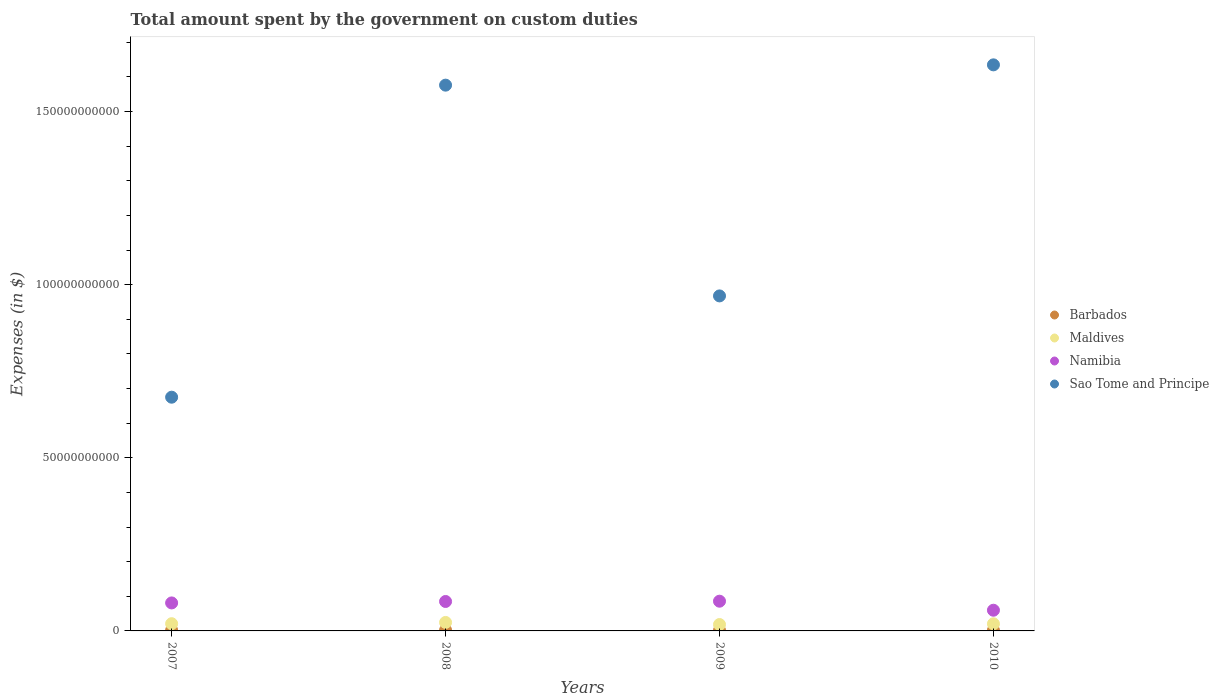How many different coloured dotlines are there?
Make the answer very short. 4. Is the number of dotlines equal to the number of legend labels?
Ensure brevity in your answer.  Yes. What is the amount spent on custom duties by the government in Namibia in 2009?
Your response must be concise. 8.59e+09. Across all years, what is the maximum amount spent on custom duties by the government in Sao Tome and Principe?
Provide a succinct answer. 1.63e+11. Across all years, what is the minimum amount spent on custom duties by the government in Namibia?
Your answer should be compact. 5.98e+09. In which year was the amount spent on custom duties by the government in Sao Tome and Principe minimum?
Your answer should be compact. 2007. What is the total amount spent on custom duties by the government in Barbados in the graph?
Your answer should be very brief. 8.05e+08. What is the difference between the amount spent on custom duties by the government in Namibia in 2008 and that in 2009?
Offer a very short reply. -8.30e+07. What is the difference between the amount spent on custom duties by the government in Barbados in 2010 and the amount spent on custom duties by the government in Maldives in 2008?
Give a very brief answer. -2.26e+09. What is the average amount spent on custom duties by the government in Barbados per year?
Provide a succinct answer. 2.01e+08. In the year 2008, what is the difference between the amount spent on custom duties by the government in Barbados and amount spent on custom duties by the government in Sao Tome and Principe?
Make the answer very short. -1.57e+11. What is the ratio of the amount spent on custom duties by the government in Sao Tome and Principe in 2007 to that in 2009?
Your response must be concise. 0.7. What is the difference between the highest and the second highest amount spent on custom duties by the government in Sao Tome and Principe?
Ensure brevity in your answer.  5.86e+09. What is the difference between the highest and the lowest amount spent on custom duties by the government in Maldives?
Provide a short and direct response. 6.00e+08. Is it the case that in every year, the sum of the amount spent on custom duties by the government in Sao Tome and Principe and amount spent on custom duties by the government in Maldives  is greater than the sum of amount spent on custom duties by the government in Namibia and amount spent on custom duties by the government in Barbados?
Your answer should be very brief. No. Does the amount spent on custom duties by the government in Barbados monotonically increase over the years?
Keep it short and to the point. No. How many years are there in the graph?
Your answer should be very brief. 4. Are the values on the major ticks of Y-axis written in scientific E-notation?
Make the answer very short. No. Does the graph contain any zero values?
Offer a very short reply. No. Does the graph contain grids?
Offer a very short reply. No. What is the title of the graph?
Offer a terse response. Total amount spent by the government on custom duties. What is the label or title of the X-axis?
Keep it short and to the point. Years. What is the label or title of the Y-axis?
Provide a short and direct response. Expenses (in $). What is the Expenses (in $) of Barbados in 2007?
Make the answer very short. 2.17e+08. What is the Expenses (in $) in Maldives in 2007?
Offer a terse response. 2.09e+09. What is the Expenses (in $) of Namibia in 2007?
Your answer should be very brief. 8.09e+09. What is the Expenses (in $) of Sao Tome and Principe in 2007?
Your answer should be very brief. 6.75e+1. What is the Expenses (in $) of Barbados in 2008?
Your response must be concise. 2.19e+08. What is the Expenses (in $) in Maldives in 2008?
Offer a terse response. 2.45e+09. What is the Expenses (in $) in Namibia in 2008?
Ensure brevity in your answer.  8.50e+09. What is the Expenses (in $) of Sao Tome and Principe in 2008?
Offer a very short reply. 1.58e+11. What is the Expenses (in $) of Barbados in 2009?
Ensure brevity in your answer.  1.78e+08. What is the Expenses (in $) in Maldives in 2009?
Your answer should be compact. 1.85e+09. What is the Expenses (in $) of Namibia in 2009?
Give a very brief answer. 8.59e+09. What is the Expenses (in $) in Sao Tome and Principe in 2009?
Make the answer very short. 9.67e+1. What is the Expenses (in $) of Barbados in 2010?
Your answer should be very brief. 1.91e+08. What is the Expenses (in $) of Maldives in 2010?
Make the answer very short. 2.06e+09. What is the Expenses (in $) in Namibia in 2010?
Your answer should be compact. 5.98e+09. What is the Expenses (in $) in Sao Tome and Principe in 2010?
Keep it short and to the point. 1.63e+11. Across all years, what is the maximum Expenses (in $) of Barbados?
Ensure brevity in your answer.  2.19e+08. Across all years, what is the maximum Expenses (in $) of Maldives?
Ensure brevity in your answer.  2.45e+09. Across all years, what is the maximum Expenses (in $) in Namibia?
Offer a terse response. 8.59e+09. Across all years, what is the maximum Expenses (in $) in Sao Tome and Principe?
Provide a succinct answer. 1.63e+11. Across all years, what is the minimum Expenses (in $) of Barbados?
Provide a succinct answer. 1.78e+08. Across all years, what is the minimum Expenses (in $) of Maldives?
Keep it short and to the point. 1.85e+09. Across all years, what is the minimum Expenses (in $) of Namibia?
Provide a succinct answer. 5.98e+09. Across all years, what is the minimum Expenses (in $) in Sao Tome and Principe?
Make the answer very short. 6.75e+1. What is the total Expenses (in $) of Barbados in the graph?
Offer a terse response. 8.05e+08. What is the total Expenses (in $) in Maldives in the graph?
Keep it short and to the point. 8.44e+09. What is the total Expenses (in $) in Namibia in the graph?
Give a very brief answer. 3.11e+1. What is the total Expenses (in $) in Sao Tome and Principe in the graph?
Your response must be concise. 4.85e+11. What is the difference between the Expenses (in $) of Barbados in 2007 and that in 2008?
Provide a short and direct response. -2.52e+06. What is the difference between the Expenses (in $) in Maldives in 2007 and that in 2008?
Your answer should be very brief. -3.62e+08. What is the difference between the Expenses (in $) of Namibia in 2007 and that in 2008?
Keep it short and to the point. -4.17e+08. What is the difference between the Expenses (in $) in Sao Tome and Principe in 2007 and that in 2008?
Make the answer very short. -9.01e+1. What is the difference between the Expenses (in $) in Barbados in 2007 and that in 2009?
Keep it short and to the point. 3.90e+07. What is the difference between the Expenses (in $) of Maldives in 2007 and that in 2009?
Keep it short and to the point. 2.38e+08. What is the difference between the Expenses (in $) in Namibia in 2007 and that in 2009?
Offer a very short reply. -5.00e+08. What is the difference between the Expenses (in $) in Sao Tome and Principe in 2007 and that in 2009?
Keep it short and to the point. -2.93e+1. What is the difference between the Expenses (in $) of Barbados in 2007 and that in 2010?
Ensure brevity in your answer.  2.61e+07. What is the difference between the Expenses (in $) in Maldives in 2007 and that in 2010?
Make the answer very short. 3.07e+07. What is the difference between the Expenses (in $) in Namibia in 2007 and that in 2010?
Offer a very short reply. 2.11e+09. What is the difference between the Expenses (in $) in Sao Tome and Principe in 2007 and that in 2010?
Keep it short and to the point. -9.60e+1. What is the difference between the Expenses (in $) of Barbados in 2008 and that in 2009?
Provide a short and direct response. 4.15e+07. What is the difference between the Expenses (in $) in Maldives in 2008 and that in 2009?
Your answer should be very brief. 6.00e+08. What is the difference between the Expenses (in $) in Namibia in 2008 and that in 2009?
Make the answer very short. -8.30e+07. What is the difference between the Expenses (in $) of Sao Tome and Principe in 2008 and that in 2009?
Provide a succinct answer. 6.09e+1. What is the difference between the Expenses (in $) of Barbados in 2008 and that in 2010?
Make the answer very short. 2.87e+07. What is the difference between the Expenses (in $) of Maldives in 2008 and that in 2010?
Your answer should be very brief. 3.93e+08. What is the difference between the Expenses (in $) in Namibia in 2008 and that in 2010?
Make the answer very short. 2.53e+09. What is the difference between the Expenses (in $) in Sao Tome and Principe in 2008 and that in 2010?
Ensure brevity in your answer.  -5.86e+09. What is the difference between the Expenses (in $) in Barbados in 2009 and that in 2010?
Make the answer very short. -1.28e+07. What is the difference between the Expenses (in $) in Maldives in 2009 and that in 2010?
Offer a very short reply. -2.07e+08. What is the difference between the Expenses (in $) of Namibia in 2009 and that in 2010?
Provide a succinct answer. 2.61e+09. What is the difference between the Expenses (in $) of Sao Tome and Principe in 2009 and that in 2010?
Make the answer very short. -6.67e+1. What is the difference between the Expenses (in $) of Barbados in 2007 and the Expenses (in $) of Maldives in 2008?
Your answer should be compact. -2.23e+09. What is the difference between the Expenses (in $) of Barbados in 2007 and the Expenses (in $) of Namibia in 2008?
Your answer should be compact. -8.29e+09. What is the difference between the Expenses (in $) in Barbados in 2007 and the Expenses (in $) in Sao Tome and Principe in 2008?
Give a very brief answer. -1.57e+11. What is the difference between the Expenses (in $) in Maldives in 2007 and the Expenses (in $) in Namibia in 2008?
Keep it short and to the point. -6.42e+09. What is the difference between the Expenses (in $) in Maldives in 2007 and the Expenses (in $) in Sao Tome and Principe in 2008?
Keep it short and to the point. -1.56e+11. What is the difference between the Expenses (in $) in Namibia in 2007 and the Expenses (in $) in Sao Tome and Principe in 2008?
Your response must be concise. -1.50e+11. What is the difference between the Expenses (in $) of Barbados in 2007 and the Expenses (in $) of Maldives in 2009?
Provide a short and direct response. -1.63e+09. What is the difference between the Expenses (in $) in Barbados in 2007 and the Expenses (in $) in Namibia in 2009?
Ensure brevity in your answer.  -8.37e+09. What is the difference between the Expenses (in $) of Barbados in 2007 and the Expenses (in $) of Sao Tome and Principe in 2009?
Provide a succinct answer. -9.65e+1. What is the difference between the Expenses (in $) in Maldives in 2007 and the Expenses (in $) in Namibia in 2009?
Offer a terse response. -6.50e+09. What is the difference between the Expenses (in $) of Maldives in 2007 and the Expenses (in $) of Sao Tome and Principe in 2009?
Ensure brevity in your answer.  -9.47e+1. What is the difference between the Expenses (in $) in Namibia in 2007 and the Expenses (in $) in Sao Tome and Principe in 2009?
Ensure brevity in your answer.  -8.87e+1. What is the difference between the Expenses (in $) in Barbados in 2007 and the Expenses (in $) in Maldives in 2010?
Your answer should be compact. -1.84e+09. What is the difference between the Expenses (in $) of Barbados in 2007 and the Expenses (in $) of Namibia in 2010?
Provide a succinct answer. -5.76e+09. What is the difference between the Expenses (in $) of Barbados in 2007 and the Expenses (in $) of Sao Tome and Principe in 2010?
Make the answer very short. -1.63e+11. What is the difference between the Expenses (in $) in Maldives in 2007 and the Expenses (in $) in Namibia in 2010?
Provide a short and direct response. -3.89e+09. What is the difference between the Expenses (in $) in Maldives in 2007 and the Expenses (in $) in Sao Tome and Principe in 2010?
Give a very brief answer. -1.61e+11. What is the difference between the Expenses (in $) in Namibia in 2007 and the Expenses (in $) in Sao Tome and Principe in 2010?
Your response must be concise. -1.55e+11. What is the difference between the Expenses (in $) of Barbados in 2008 and the Expenses (in $) of Maldives in 2009?
Ensure brevity in your answer.  -1.63e+09. What is the difference between the Expenses (in $) in Barbados in 2008 and the Expenses (in $) in Namibia in 2009?
Ensure brevity in your answer.  -8.37e+09. What is the difference between the Expenses (in $) of Barbados in 2008 and the Expenses (in $) of Sao Tome and Principe in 2009?
Offer a terse response. -9.65e+1. What is the difference between the Expenses (in $) in Maldives in 2008 and the Expenses (in $) in Namibia in 2009?
Keep it short and to the point. -6.14e+09. What is the difference between the Expenses (in $) of Maldives in 2008 and the Expenses (in $) of Sao Tome and Principe in 2009?
Your answer should be compact. -9.43e+1. What is the difference between the Expenses (in $) in Namibia in 2008 and the Expenses (in $) in Sao Tome and Principe in 2009?
Your answer should be compact. -8.82e+1. What is the difference between the Expenses (in $) of Barbados in 2008 and the Expenses (in $) of Maldives in 2010?
Your response must be concise. -1.84e+09. What is the difference between the Expenses (in $) in Barbados in 2008 and the Expenses (in $) in Namibia in 2010?
Provide a succinct answer. -5.76e+09. What is the difference between the Expenses (in $) of Barbados in 2008 and the Expenses (in $) of Sao Tome and Principe in 2010?
Keep it short and to the point. -1.63e+11. What is the difference between the Expenses (in $) of Maldives in 2008 and the Expenses (in $) of Namibia in 2010?
Your answer should be compact. -3.53e+09. What is the difference between the Expenses (in $) in Maldives in 2008 and the Expenses (in $) in Sao Tome and Principe in 2010?
Provide a succinct answer. -1.61e+11. What is the difference between the Expenses (in $) of Namibia in 2008 and the Expenses (in $) of Sao Tome and Principe in 2010?
Your answer should be very brief. -1.55e+11. What is the difference between the Expenses (in $) in Barbados in 2009 and the Expenses (in $) in Maldives in 2010?
Make the answer very short. -1.88e+09. What is the difference between the Expenses (in $) in Barbados in 2009 and the Expenses (in $) in Namibia in 2010?
Ensure brevity in your answer.  -5.80e+09. What is the difference between the Expenses (in $) in Barbados in 2009 and the Expenses (in $) in Sao Tome and Principe in 2010?
Make the answer very short. -1.63e+11. What is the difference between the Expenses (in $) of Maldives in 2009 and the Expenses (in $) of Namibia in 2010?
Provide a short and direct response. -4.13e+09. What is the difference between the Expenses (in $) in Maldives in 2009 and the Expenses (in $) in Sao Tome and Principe in 2010?
Your response must be concise. -1.62e+11. What is the difference between the Expenses (in $) in Namibia in 2009 and the Expenses (in $) in Sao Tome and Principe in 2010?
Offer a terse response. -1.55e+11. What is the average Expenses (in $) in Barbados per year?
Ensure brevity in your answer.  2.01e+08. What is the average Expenses (in $) of Maldives per year?
Offer a very short reply. 2.11e+09. What is the average Expenses (in $) of Namibia per year?
Your response must be concise. 7.79e+09. What is the average Expenses (in $) in Sao Tome and Principe per year?
Offer a terse response. 1.21e+11. In the year 2007, what is the difference between the Expenses (in $) of Barbados and Expenses (in $) of Maldives?
Ensure brevity in your answer.  -1.87e+09. In the year 2007, what is the difference between the Expenses (in $) of Barbados and Expenses (in $) of Namibia?
Provide a succinct answer. -7.87e+09. In the year 2007, what is the difference between the Expenses (in $) of Barbados and Expenses (in $) of Sao Tome and Principe?
Provide a succinct answer. -6.73e+1. In the year 2007, what is the difference between the Expenses (in $) of Maldives and Expenses (in $) of Namibia?
Make the answer very short. -6.00e+09. In the year 2007, what is the difference between the Expenses (in $) of Maldives and Expenses (in $) of Sao Tome and Principe?
Make the answer very short. -6.54e+1. In the year 2007, what is the difference between the Expenses (in $) in Namibia and Expenses (in $) in Sao Tome and Principe?
Ensure brevity in your answer.  -5.94e+1. In the year 2008, what is the difference between the Expenses (in $) of Barbados and Expenses (in $) of Maldives?
Provide a short and direct response. -2.23e+09. In the year 2008, what is the difference between the Expenses (in $) of Barbados and Expenses (in $) of Namibia?
Provide a short and direct response. -8.28e+09. In the year 2008, what is the difference between the Expenses (in $) in Barbados and Expenses (in $) in Sao Tome and Principe?
Keep it short and to the point. -1.57e+11. In the year 2008, what is the difference between the Expenses (in $) in Maldives and Expenses (in $) in Namibia?
Provide a short and direct response. -6.05e+09. In the year 2008, what is the difference between the Expenses (in $) of Maldives and Expenses (in $) of Sao Tome and Principe?
Keep it short and to the point. -1.55e+11. In the year 2008, what is the difference between the Expenses (in $) in Namibia and Expenses (in $) in Sao Tome and Principe?
Ensure brevity in your answer.  -1.49e+11. In the year 2009, what is the difference between the Expenses (in $) in Barbados and Expenses (in $) in Maldives?
Provide a short and direct response. -1.67e+09. In the year 2009, what is the difference between the Expenses (in $) in Barbados and Expenses (in $) in Namibia?
Offer a very short reply. -8.41e+09. In the year 2009, what is the difference between the Expenses (in $) of Barbados and Expenses (in $) of Sao Tome and Principe?
Your answer should be very brief. -9.66e+1. In the year 2009, what is the difference between the Expenses (in $) in Maldives and Expenses (in $) in Namibia?
Give a very brief answer. -6.74e+09. In the year 2009, what is the difference between the Expenses (in $) in Maldives and Expenses (in $) in Sao Tome and Principe?
Provide a short and direct response. -9.49e+1. In the year 2009, what is the difference between the Expenses (in $) in Namibia and Expenses (in $) in Sao Tome and Principe?
Provide a succinct answer. -8.82e+1. In the year 2010, what is the difference between the Expenses (in $) in Barbados and Expenses (in $) in Maldives?
Make the answer very short. -1.87e+09. In the year 2010, what is the difference between the Expenses (in $) of Barbados and Expenses (in $) of Namibia?
Your response must be concise. -5.79e+09. In the year 2010, what is the difference between the Expenses (in $) in Barbados and Expenses (in $) in Sao Tome and Principe?
Provide a succinct answer. -1.63e+11. In the year 2010, what is the difference between the Expenses (in $) in Maldives and Expenses (in $) in Namibia?
Offer a terse response. -3.92e+09. In the year 2010, what is the difference between the Expenses (in $) in Maldives and Expenses (in $) in Sao Tome and Principe?
Offer a terse response. -1.61e+11. In the year 2010, what is the difference between the Expenses (in $) in Namibia and Expenses (in $) in Sao Tome and Principe?
Offer a terse response. -1.58e+11. What is the ratio of the Expenses (in $) of Barbados in 2007 to that in 2008?
Make the answer very short. 0.99. What is the ratio of the Expenses (in $) in Maldives in 2007 to that in 2008?
Keep it short and to the point. 0.85. What is the ratio of the Expenses (in $) in Namibia in 2007 to that in 2008?
Provide a short and direct response. 0.95. What is the ratio of the Expenses (in $) of Sao Tome and Principe in 2007 to that in 2008?
Offer a very short reply. 0.43. What is the ratio of the Expenses (in $) of Barbados in 2007 to that in 2009?
Make the answer very short. 1.22. What is the ratio of the Expenses (in $) of Maldives in 2007 to that in 2009?
Your answer should be very brief. 1.13. What is the ratio of the Expenses (in $) in Namibia in 2007 to that in 2009?
Offer a very short reply. 0.94. What is the ratio of the Expenses (in $) of Sao Tome and Principe in 2007 to that in 2009?
Your response must be concise. 0.7. What is the ratio of the Expenses (in $) in Barbados in 2007 to that in 2010?
Offer a very short reply. 1.14. What is the ratio of the Expenses (in $) in Maldives in 2007 to that in 2010?
Your answer should be compact. 1.01. What is the ratio of the Expenses (in $) of Namibia in 2007 to that in 2010?
Your answer should be very brief. 1.35. What is the ratio of the Expenses (in $) in Sao Tome and Principe in 2007 to that in 2010?
Your answer should be very brief. 0.41. What is the ratio of the Expenses (in $) in Barbados in 2008 to that in 2009?
Your answer should be very brief. 1.23. What is the ratio of the Expenses (in $) of Maldives in 2008 to that in 2009?
Give a very brief answer. 1.32. What is the ratio of the Expenses (in $) of Namibia in 2008 to that in 2009?
Provide a succinct answer. 0.99. What is the ratio of the Expenses (in $) of Sao Tome and Principe in 2008 to that in 2009?
Provide a short and direct response. 1.63. What is the ratio of the Expenses (in $) in Barbados in 2008 to that in 2010?
Provide a succinct answer. 1.15. What is the ratio of the Expenses (in $) in Maldives in 2008 to that in 2010?
Provide a short and direct response. 1.19. What is the ratio of the Expenses (in $) in Namibia in 2008 to that in 2010?
Offer a very short reply. 1.42. What is the ratio of the Expenses (in $) in Sao Tome and Principe in 2008 to that in 2010?
Offer a terse response. 0.96. What is the ratio of the Expenses (in $) in Barbados in 2009 to that in 2010?
Provide a short and direct response. 0.93. What is the ratio of the Expenses (in $) in Maldives in 2009 to that in 2010?
Your answer should be compact. 0.9. What is the ratio of the Expenses (in $) in Namibia in 2009 to that in 2010?
Your answer should be very brief. 1.44. What is the ratio of the Expenses (in $) in Sao Tome and Principe in 2009 to that in 2010?
Make the answer very short. 0.59. What is the difference between the highest and the second highest Expenses (in $) in Barbados?
Keep it short and to the point. 2.52e+06. What is the difference between the highest and the second highest Expenses (in $) of Maldives?
Keep it short and to the point. 3.62e+08. What is the difference between the highest and the second highest Expenses (in $) of Namibia?
Your answer should be very brief. 8.30e+07. What is the difference between the highest and the second highest Expenses (in $) in Sao Tome and Principe?
Your response must be concise. 5.86e+09. What is the difference between the highest and the lowest Expenses (in $) of Barbados?
Keep it short and to the point. 4.15e+07. What is the difference between the highest and the lowest Expenses (in $) in Maldives?
Your answer should be compact. 6.00e+08. What is the difference between the highest and the lowest Expenses (in $) of Namibia?
Offer a terse response. 2.61e+09. What is the difference between the highest and the lowest Expenses (in $) of Sao Tome and Principe?
Ensure brevity in your answer.  9.60e+1. 